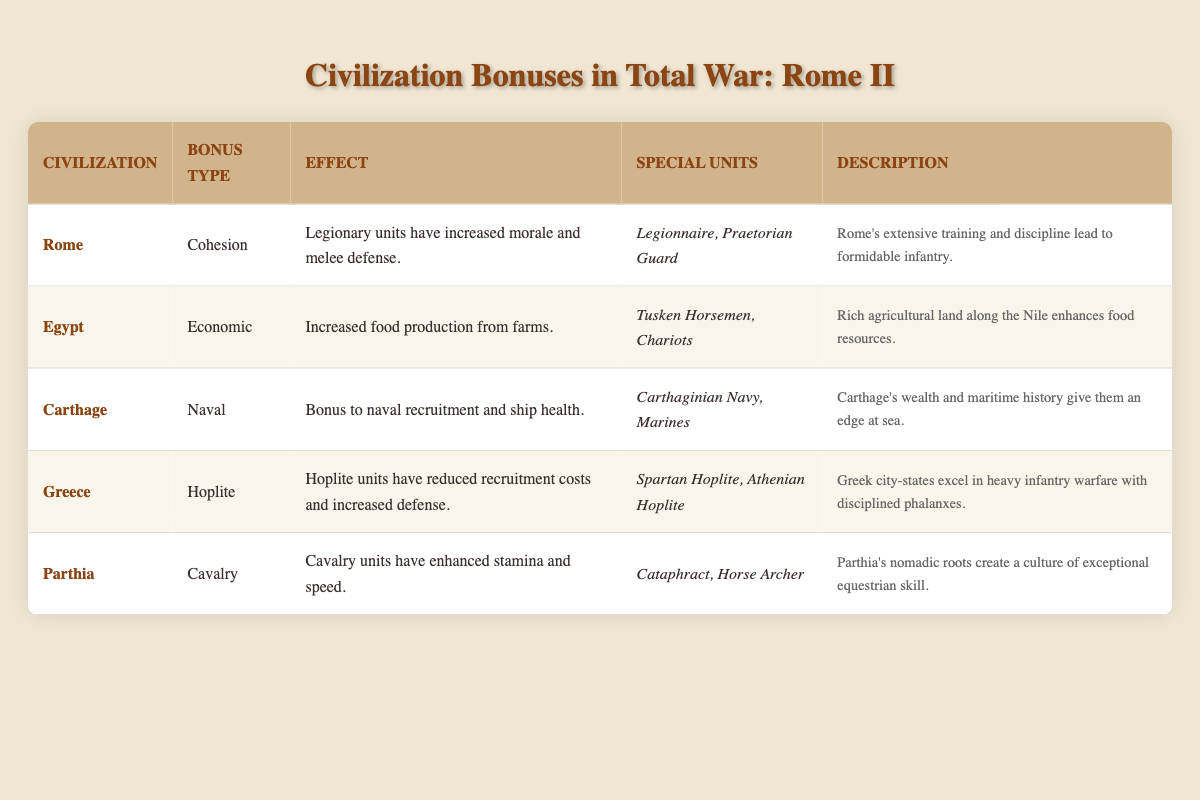What civilization has a naval bonus? The table lists Carthage as having a naval bonus. The row under Carthage indicates that they receive a bonus to naval recruitment and ship health, clearly identifying their naval advantage.
Answer: Carthage Which civilization's units have increased morale and melee defense? The table specifies that Rome's legionary units benefit from increased morale and melee defense. This information is found in the row dedicated to Rome.
Answer: Rome Is Egypt's bonus related to military units? The table indicates Egypt's bonus is economic, specifically increasing food production from farms. Thus, it does not relate to military enhancements, leading to a clear no answer.
Answer: No What are the special units for Greece? The table shows that Greece's special units are Spartan Hoplites and Athenian Hoplites. These are explicitly listed under the Greece entry in the table.
Answer: Spartan Hoplite, Athenian Hoplite Which civilization has enhanced cavalry units? The table indicates that Parthia benefits from enhanced cavalry units, specifically with increased stamina and speed. This is clearly stated in the row for Parthia.
Answer: Parthia What is the difference in bonus type between Carthage and Egypt? Carthage has a naval bonus while Egypt has an economic bonus, representing a distinct difference in their strategic advantages as outlined in the table. Therefore, the difference is naval versus economic benefits.
Answer: Naval vs. Economic Do Greek units have reduced recruitment costs? The table confirms that Greek hoplite units do indeed have reduced recruitment costs, making the statement true when referring to the information presented for Greece.
Answer: Yes What civilization benefits from increased food production, and what unit types do they have? Egypt is identified in the table as receiving increased food production from farms. The special units mentioned are Tusken Horsemen and Chariots, both listed under Egypt’s entry.
Answer: Egypt, Tusken Horsemen, Chariots Based on the bonuses described, which civilization is best suited for cavalry warfare? The table states that Parthia has enhanced stamina and speed for cavalry units, indicating they are best suited for cavalry warfare. In comparison with other civilizations, none are mentioned with similar bonuses specific to cavalry, affirming Parthia's advantage.
Answer: Parthia 